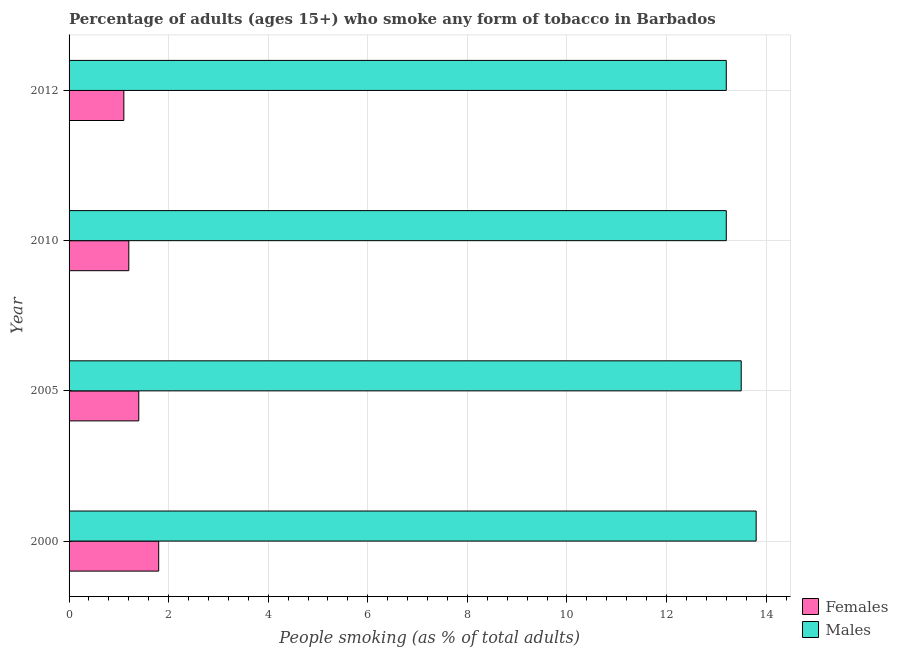How many different coloured bars are there?
Offer a very short reply. 2. Are the number of bars per tick equal to the number of legend labels?
Your answer should be very brief. Yes. Are the number of bars on each tick of the Y-axis equal?
Offer a very short reply. Yes. How many bars are there on the 2nd tick from the top?
Give a very brief answer. 2. How many bars are there on the 2nd tick from the bottom?
Your answer should be compact. 2. What is the label of the 1st group of bars from the top?
Your answer should be very brief. 2012. What is the percentage of females who smoke in 2010?
Provide a succinct answer. 1.2. Across all years, what is the maximum percentage of females who smoke?
Your answer should be very brief. 1.8. What is the difference between the percentage of males who smoke in 2000 and that in 2005?
Your response must be concise. 0.3. What is the difference between the percentage of males who smoke in 2010 and the percentage of females who smoke in 2012?
Offer a terse response. 12.1. What is the average percentage of females who smoke per year?
Make the answer very short. 1.38. In how many years, is the percentage of males who smoke greater than 8.8 %?
Make the answer very short. 4. What is the ratio of the percentage of females who smoke in 2005 to that in 2012?
Your response must be concise. 1.27. Is the percentage of males who smoke in 2000 less than that in 2005?
Offer a terse response. No. What is the difference between the highest and the lowest percentage of males who smoke?
Your answer should be compact. 0.6. In how many years, is the percentage of males who smoke greater than the average percentage of males who smoke taken over all years?
Keep it short and to the point. 2. Is the sum of the percentage of males who smoke in 2000 and 2005 greater than the maximum percentage of females who smoke across all years?
Your response must be concise. Yes. What does the 1st bar from the top in 2010 represents?
Your response must be concise. Males. What does the 2nd bar from the bottom in 2012 represents?
Your response must be concise. Males. Are all the bars in the graph horizontal?
Make the answer very short. Yes. How many legend labels are there?
Provide a succinct answer. 2. What is the title of the graph?
Offer a very short reply. Percentage of adults (ages 15+) who smoke any form of tobacco in Barbados. What is the label or title of the X-axis?
Offer a terse response. People smoking (as % of total adults). What is the label or title of the Y-axis?
Give a very brief answer. Year. What is the People smoking (as % of total adults) in Females in 2000?
Your answer should be very brief. 1.8. What is the People smoking (as % of total adults) of Females in 2005?
Your response must be concise. 1.4. Across all years, what is the maximum People smoking (as % of total adults) in Females?
Offer a terse response. 1.8. Across all years, what is the minimum People smoking (as % of total adults) of Females?
Ensure brevity in your answer.  1.1. What is the total People smoking (as % of total adults) of Males in the graph?
Make the answer very short. 53.7. What is the difference between the People smoking (as % of total adults) in Females in 2000 and that in 2005?
Offer a very short reply. 0.4. What is the difference between the People smoking (as % of total adults) of Males in 2000 and that in 2005?
Make the answer very short. 0.3. What is the difference between the People smoking (as % of total adults) of Females in 2000 and that in 2010?
Provide a succinct answer. 0.6. What is the difference between the People smoking (as % of total adults) in Males in 2000 and that in 2010?
Your answer should be very brief. 0.6. What is the difference between the People smoking (as % of total adults) of Males in 2000 and that in 2012?
Make the answer very short. 0.6. What is the difference between the People smoking (as % of total adults) of Males in 2005 and that in 2010?
Provide a succinct answer. 0.3. What is the difference between the People smoking (as % of total adults) in Females in 2010 and that in 2012?
Offer a very short reply. 0.1. What is the difference between the People smoking (as % of total adults) of Females in 2000 and the People smoking (as % of total adults) of Males in 2005?
Offer a very short reply. -11.7. What is the difference between the People smoking (as % of total adults) of Females in 2000 and the People smoking (as % of total adults) of Males in 2010?
Keep it short and to the point. -11.4. What is the difference between the People smoking (as % of total adults) in Females in 2005 and the People smoking (as % of total adults) in Males in 2010?
Your answer should be very brief. -11.8. What is the average People smoking (as % of total adults) in Females per year?
Provide a succinct answer. 1.38. What is the average People smoking (as % of total adults) in Males per year?
Your response must be concise. 13.43. In the year 2000, what is the difference between the People smoking (as % of total adults) of Females and People smoking (as % of total adults) of Males?
Make the answer very short. -12. In the year 2012, what is the difference between the People smoking (as % of total adults) of Females and People smoking (as % of total adults) of Males?
Offer a very short reply. -12.1. What is the ratio of the People smoking (as % of total adults) of Males in 2000 to that in 2005?
Offer a terse response. 1.02. What is the ratio of the People smoking (as % of total adults) of Females in 2000 to that in 2010?
Provide a short and direct response. 1.5. What is the ratio of the People smoking (as % of total adults) of Males in 2000 to that in 2010?
Provide a short and direct response. 1.05. What is the ratio of the People smoking (as % of total adults) in Females in 2000 to that in 2012?
Provide a succinct answer. 1.64. What is the ratio of the People smoking (as % of total adults) of Males in 2000 to that in 2012?
Keep it short and to the point. 1.05. What is the ratio of the People smoking (as % of total adults) in Females in 2005 to that in 2010?
Give a very brief answer. 1.17. What is the ratio of the People smoking (as % of total adults) of Males in 2005 to that in 2010?
Keep it short and to the point. 1.02. What is the ratio of the People smoking (as % of total adults) of Females in 2005 to that in 2012?
Make the answer very short. 1.27. What is the ratio of the People smoking (as % of total adults) of Males in 2005 to that in 2012?
Your answer should be compact. 1.02. What is the ratio of the People smoking (as % of total adults) of Males in 2010 to that in 2012?
Provide a short and direct response. 1. What is the difference between the highest and the second highest People smoking (as % of total adults) in Females?
Offer a very short reply. 0.4. 